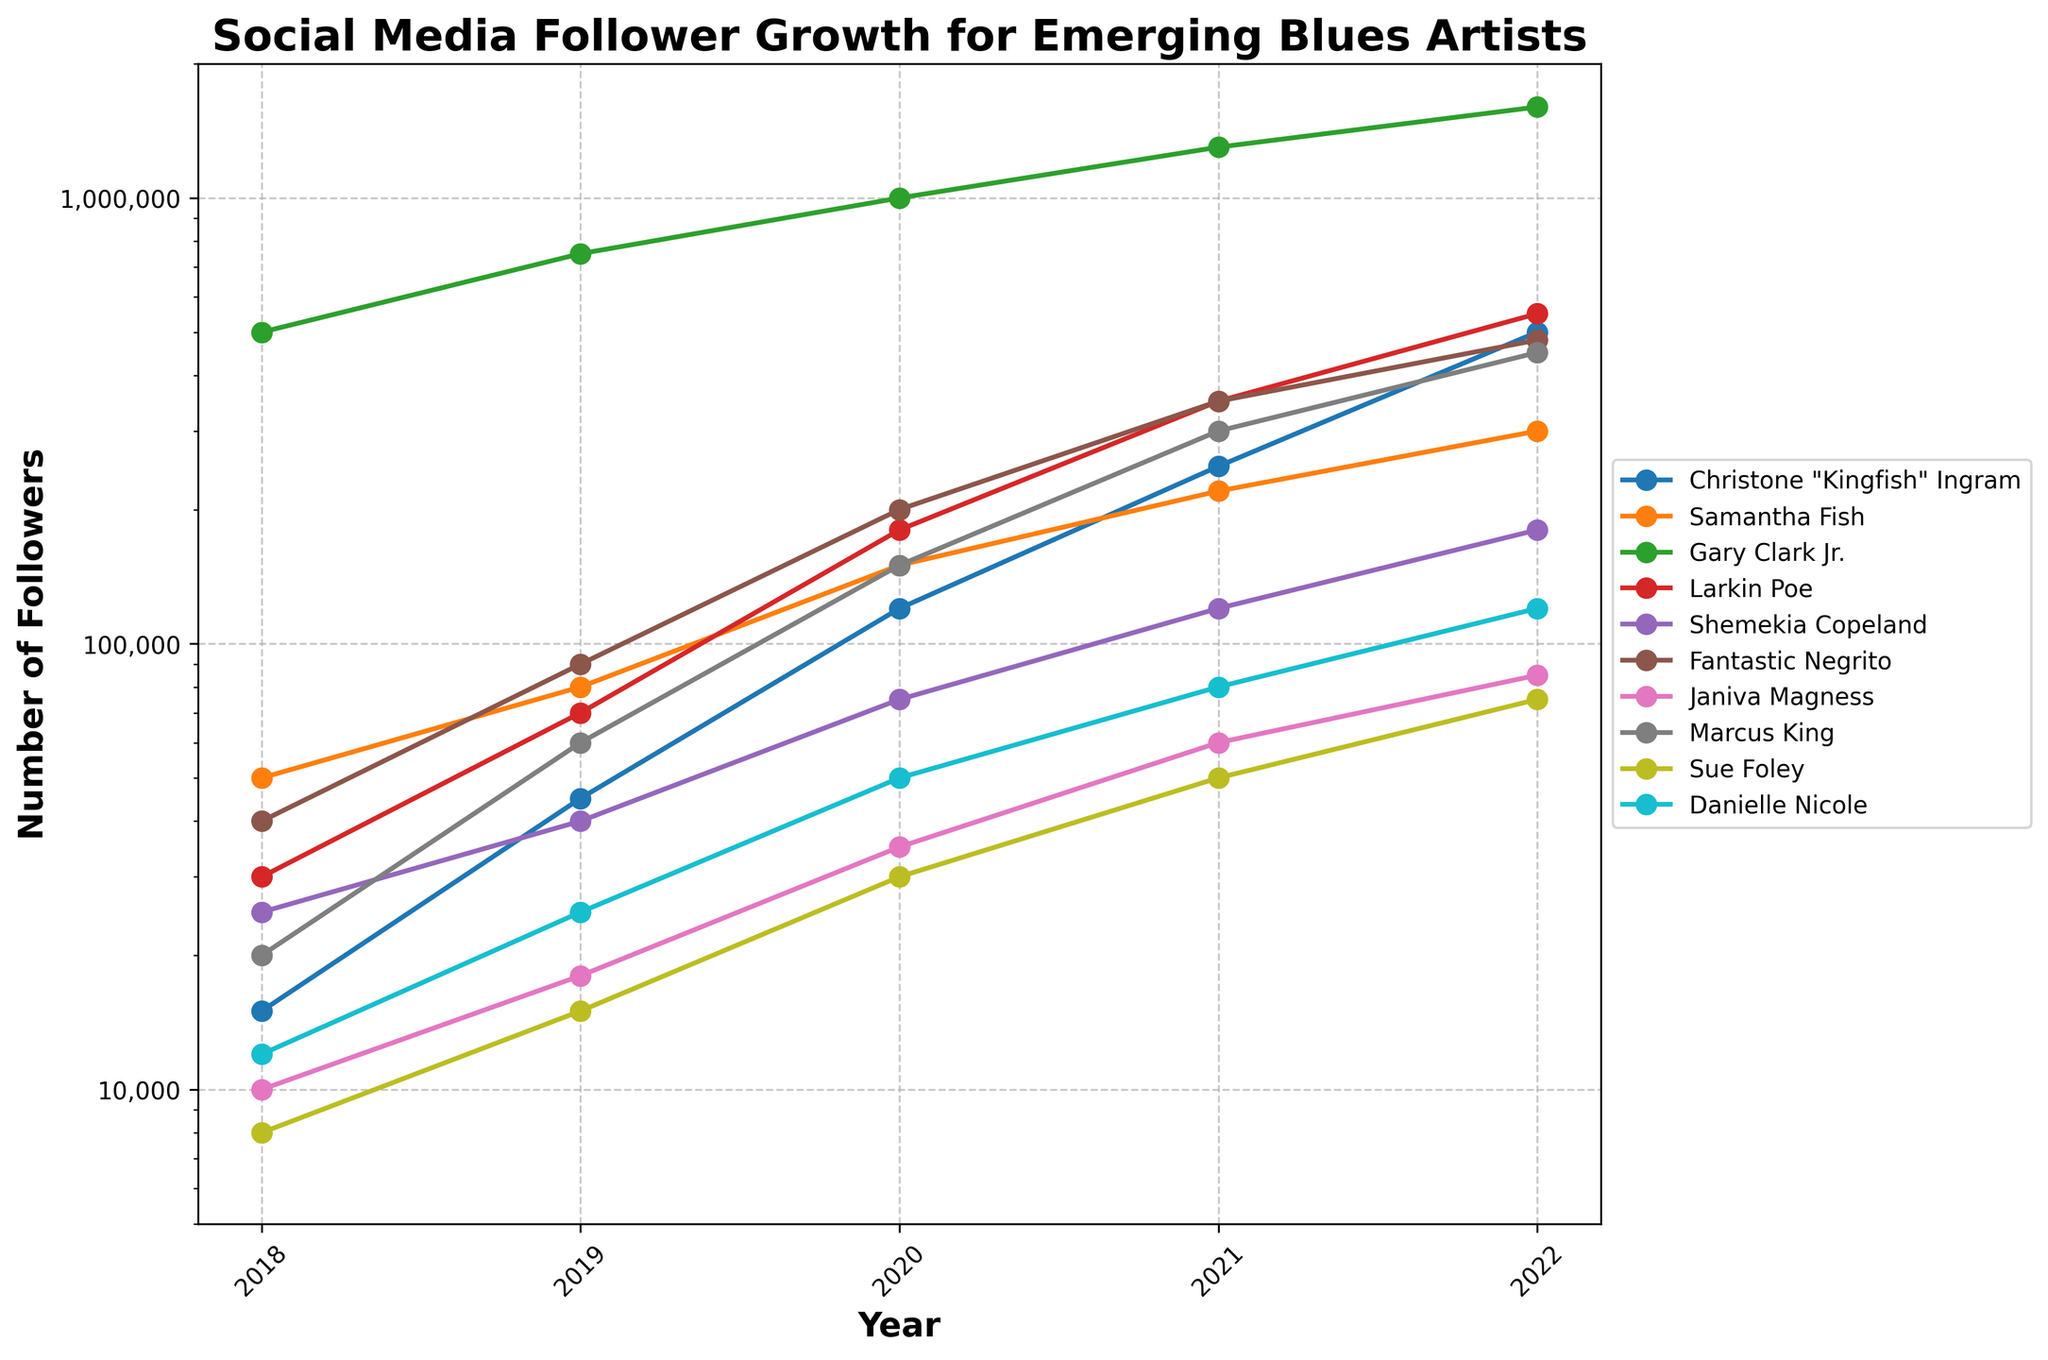Which artist had the highest number of followers in 2022? The line that reaches the highest point on the y-axis in 2022 corresponds to the artist with the most followers. Gary Clark Jr. has the highest number of followers in 2022.
Answer: Gary Clark Jr How many artists had more than 100,000 followers in 2020? Look along the 2020 axis and count the number of lines above the 100,000 mark. Six artists had more than 100,000 followers: Christone "Kingfish" Ingram, Samantha Fish, Gary Clark Jr., Larkin Poe, Fantastic Negrito, and Marcus King.
Answer: 6 Who showed the most significant growth in followers between 2018 and 2022? Compare the differences in followers for each artist between 2018 and 2022. Christone "Kingfish" Ingram seems to show the largest increase, going from 15,000 to 500,000.
Answer: Christone "Kingfish" Ingram What was the total number of followers for Larkin Poe across the years? Add the number of followers for Larkin Poe for each year from 2018 to 2022. (30,000 + 70,000 + 180,000 + 350,000 + 550,000) = 1,180,000
Answer: 1,180,000 Compare the follower growth trend of Christone "Kingfish" Ingram and Samantha Fish. Who grew faster? Compare the slope of the lines representing Christone "Kingfish" Ingram and Samantha Fish. Christone "Kingfish" Ingram's growth line is steeper, indicating faster growth.
Answer: Christone "Kingfish" Ingram Which artist had the smallest number of followers in 2018? Identify the point with the lowest value on the 2018 axis. Sue Foley had the smallest number of followers in 2018.
Answer: Sue Foley What is the average number of followers in 2019 for all artists combined? Add the 2019 follower counts for all artists and divide by the number of artists. (45000 + 80000 + 750000 + 70000 + 40000 + 90000 + 18000 + 60000 + 15000 + 25000) / 10 = 112,800
Answer: 112,800 How did the follower count of Fantastic Negrito change between 2020 and 2021? Subtract the 2020 follower count from the 2021 follower count for Fantastic Negrito. 350,000 - 200,000 = 150,000
Answer: 150,000 Compare the 2022 follower count of Danielle Nicole and Janiva Magness. Who had more followers? Check the 2022 follower values for Danielle Nicole and Janiva Magness. Danielle Nicole had 120,000 followers, while Janiva Magness had 85,000 followers. Danielle Nicole had more followers.
Answer: Danielle Nicole Who had the highest growth rate between 2021 and 2022? Determine the artist with the largest difference in followers between 2021 and 2022. Christone "Kingfish" Ingram had the highest growth from 250,000 to 500,000.
Answer: Christone "Kingfish" Ingram 